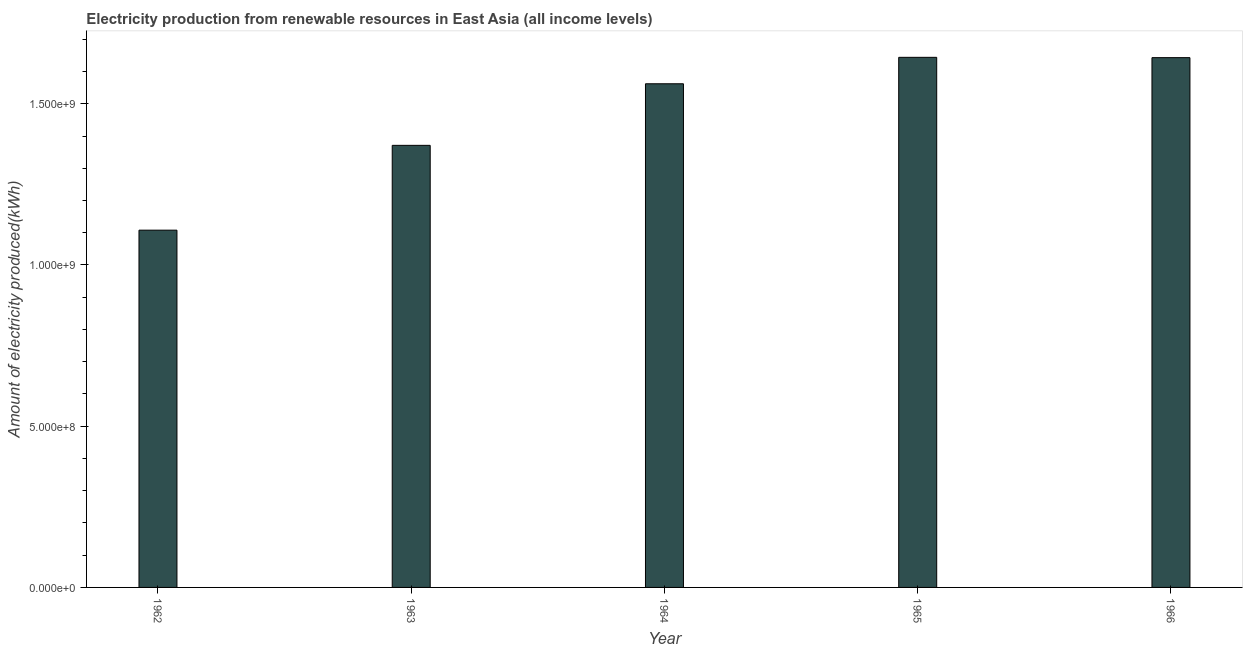Does the graph contain grids?
Give a very brief answer. No. What is the title of the graph?
Offer a terse response. Electricity production from renewable resources in East Asia (all income levels). What is the label or title of the Y-axis?
Provide a short and direct response. Amount of electricity produced(kWh). What is the amount of electricity produced in 1966?
Make the answer very short. 1.64e+09. Across all years, what is the maximum amount of electricity produced?
Provide a succinct answer. 1.64e+09. Across all years, what is the minimum amount of electricity produced?
Provide a short and direct response. 1.11e+09. In which year was the amount of electricity produced maximum?
Give a very brief answer. 1965. What is the sum of the amount of electricity produced?
Ensure brevity in your answer.  7.33e+09. What is the difference between the amount of electricity produced in 1962 and 1966?
Your response must be concise. -5.35e+08. What is the average amount of electricity produced per year?
Provide a short and direct response. 1.47e+09. What is the median amount of electricity produced?
Ensure brevity in your answer.  1.56e+09. Do a majority of the years between 1962 and 1963 (inclusive) have amount of electricity produced greater than 1600000000 kWh?
Offer a very short reply. No. What is the ratio of the amount of electricity produced in 1962 to that in 1966?
Your answer should be compact. 0.67. Is the amount of electricity produced in 1965 less than that in 1966?
Offer a very short reply. No. Is the difference between the amount of electricity produced in 1963 and 1966 greater than the difference between any two years?
Provide a short and direct response. No. What is the difference between the highest and the second highest amount of electricity produced?
Your response must be concise. 1.00e+06. What is the difference between the highest and the lowest amount of electricity produced?
Your answer should be very brief. 5.36e+08. How many bars are there?
Your answer should be very brief. 5. Are all the bars in the graph horizontal?
Offer a terse response. No. How many years are there in the graph?
Your response must be concise. 5. Are the values on the major ticks of Y-axis written in scientific E-notation?
Ensure brevity in your answer.  Yes. What is the Amount of electricity produced(kWh) in 1962?
Provide a short and direct response. 1.11e+09. What is the Amount of electricity produced(kWh) of 1963?
Give a very brief answer. 1.37e+09. What is the Amount of electricity produced(kWh) of 1964?
Offer a very short reply. 1.56e+09. What is the Amount of electricity produced(kWh) of 1965?
Make the answer very short. 1.64e+09. What is the Amount of electricity produced(kWh) of 1966?
Your response must be concise. 1.64e+09. What is the difference between the Amount of electricity produced(kWh) in 1962 and 1963?
Your answer should be very brief. -2.63e+08. What is the difference between the Amount of electricity produced(kWh) in 1962 and 1964?
Your response must be concise. -4.54e+08. What is the difference between the Amount of electricity produced(kWh) in 1962 and 1965?
Make the answer very short. -5.36e+08. What is the difference between the Amount of electricity produced(kWh) in 1962 and 1966?
Offer a terse response. -5.35e+08. What is the difference between the Amount of electricity produced(kWh) in 1963 and 1964?
Keep it short and to the point. -1.91e+08. What is the difference between the Amount of electricity produced(kWh) in 1963 and 1965?
Offer a terse response. -2.73e+08. What is the difference between the Amount of electricity produced(kWh) in 1963 and 1966?
Give a very brief answer. -2.72e+08. What is the difference between the Amount of electricity produced(kWh) in 1964 and 1965?
Make the answer very short. -8.20e+07. What is the difference between the Amount of electricity produced(kWh) in 1964 and 1966?
Your answer should be very brief. -8.10e+07. What is the ratio of the Amount of electricity produced(kWh) in 1962 to that in 1963?
Ensure brevity in your answer.  0.81. What is the ratio of the Amount of electricity produced(kWh) in 1962 to that in 1964?
Offer a terse response. 0.71. What is the ratio of the Amount of electricity produced(kWh) in 1962 to that in 1965?
Your answer should be very brief. 0.67. What is the ratio of the Amount of electricity produced(kWh) in 1962 to that in 1966?
Provide a short and direct response. 0.67. What is the ratio of the Amount of electricity produced(kWh) in 1963 to that in 1964?
Your response must be concise. 0.88. What is the ratio of the Amount of electricity produced(kWh) in 1963 to that in 1965?
Offer a terse response. 0.83. What is the ratio of the Amount of electricity produced(kWh) in 1963 to that in 1966?
Give a very brief answer. 0.83. What is the ratio of the Amount of electricity produced(kWh) in 1964 to that in 1965?
Give a very brief answer. 0.95. What is the ratio of the Amount of electricity produced(kWh) in 1964 to that in 1966?
Your answer should be very brief. 0.95. What is the ratio of the Amount of electricity produced(kWh) in 1965 to that in 1966?
Make the answer very short. 1. 